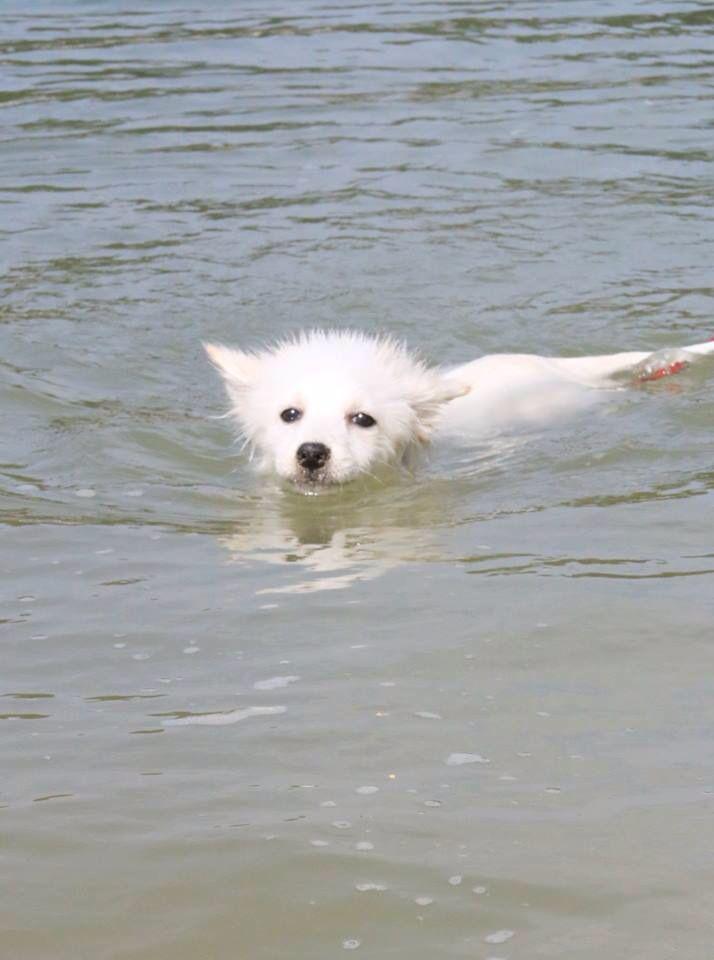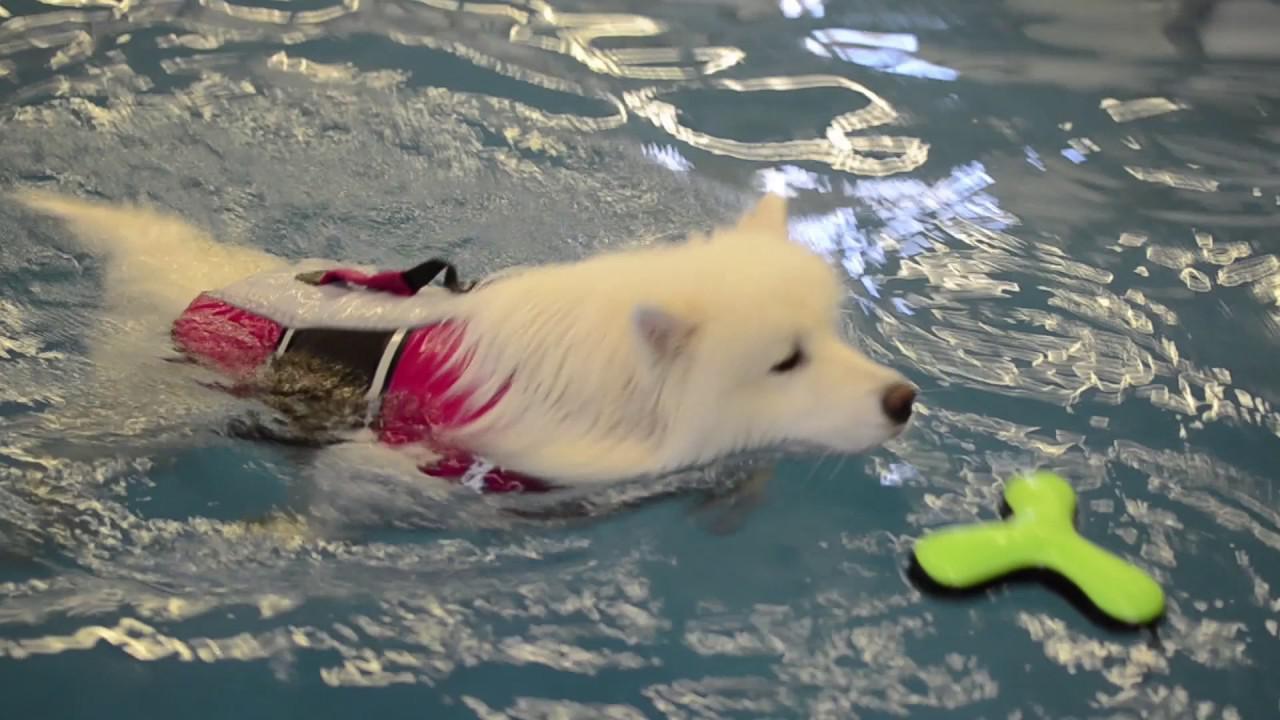The first image is the image on the left, the second image is the image on the right. Given the left and right images, does the statement "The dog in the left image is standing on the ground; he is not in the water." hold true? Answer yes or no. No. The first image is the image on the left, the second image is the image on the right. Assess this claim about the two images: "There is at least one dog that is not playing or swimming in the water.". Correct or not? Answer yes or no. No. 